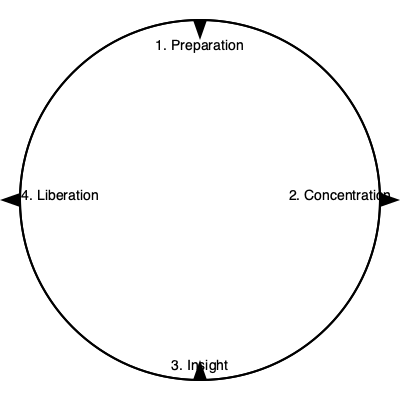In the circular flow chart depicting the stages of meditation, which stage follows "Concentration" and precedes "Liberation"? To answer this question, let's analyze the circular flow chart step-by-step:

1. The chart shows four stages of meditation in a circular, cyclical process.

2. The stages are presented in a clockwise direction, as indicated by the arrows.

3. The four stages, in order, are:
   a. Preparation
   b. Concentration
   c. Insight
   d. Liberation

4. We are asked to identify the stage that follows "Concentration" and precedes "Liberation".

5. Starting from "Concentration" and moving clockwise, we see that the next stage is "Insight".

6. After "Insight", the next stage is "Liberation", which confirms that "Insight" is indeed between "Concentration" and "Liberation".

Therefore, the stage that follows "Concentration" and precedes "Liberation" is Insight.
Answer: Insight 